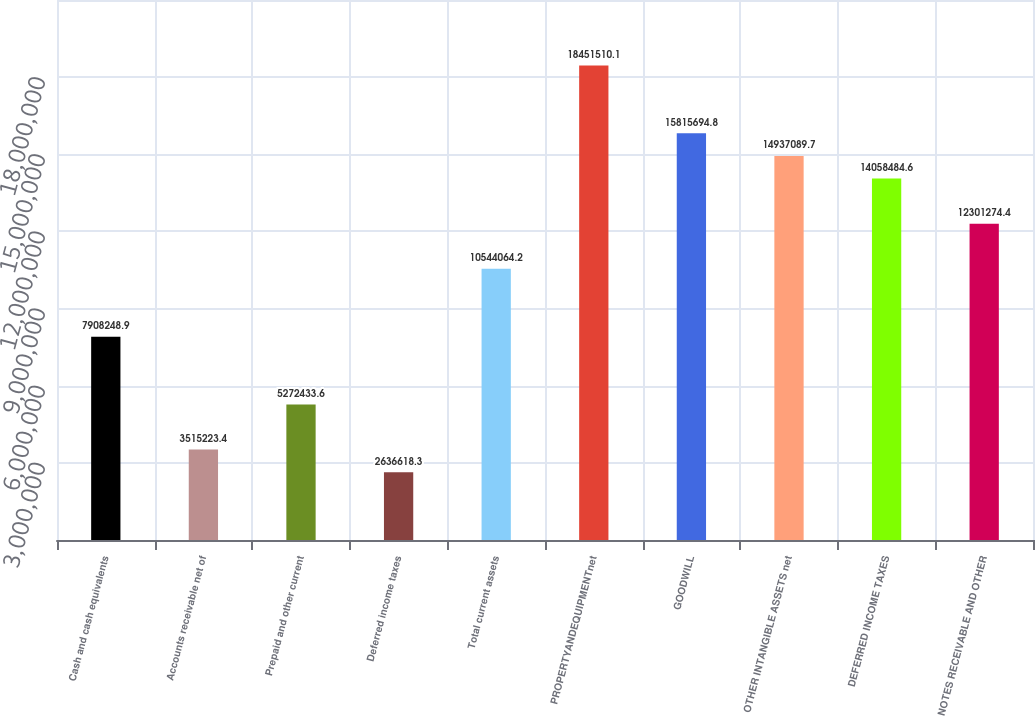<chart> <loc_0><loc_0><loc_500><loc_500><bar_chart><fcel>Cash and cash equivalents<fcel>Accounts receivable net of<fcel>Prepaid and other current<fcel>Deferred income taxes<fcel>Total current assets<fcel>PROPERTYANDEQUIPMENTnet<fcel>GOODWILL<fcel>OTHER INTANGIBLE ASSETS net<fcel>DEFERRED INCOME TAXES<fcel>NOTES RECEIVABLE AND OTHER<nl><fcel>7.90825e+06<fcel>3.51522e+06<fcel>5.27243e+06<fcel>2.63662e+06<fcel>1.05441e+07<fcel>1.84515e+07<fcel>1.58157e+07<fcel>1.49371e+07<fcel>1.40585e+07<fcel>1.23013e+07<nl></chart> 